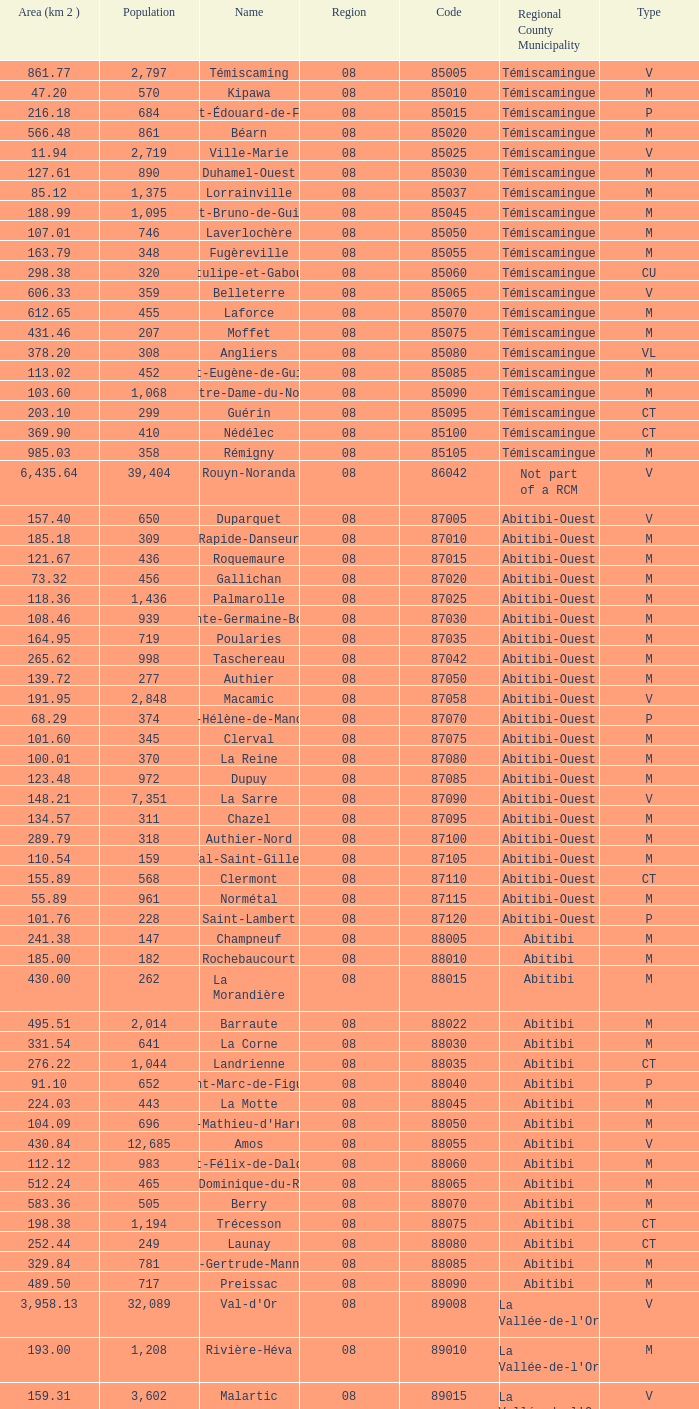What was the region for Malartic with 159.31 km2? 0.0. 